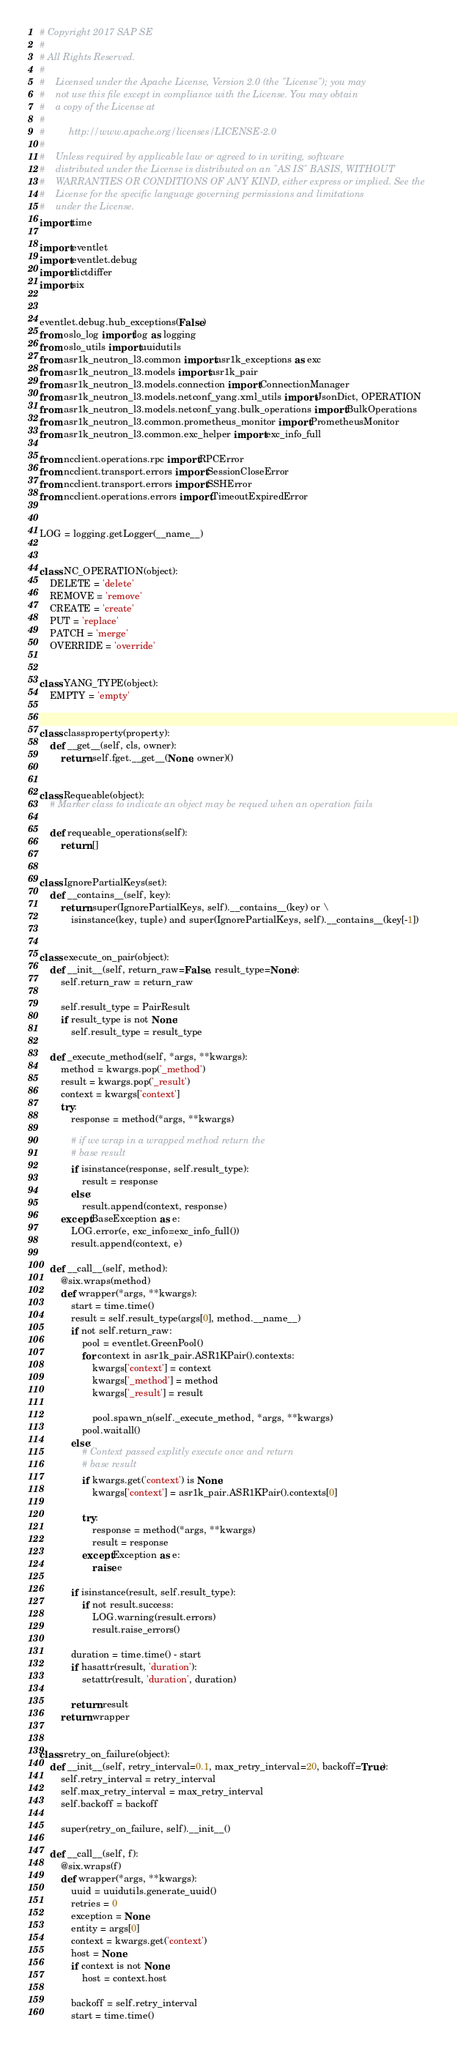<code> <loc_0><loc_0><loc_500><loc_500><_Python_># Copyright 2017 SAP SE
#
# All Rights Reserved.
#
#    Licensed under the Apache License, Version 2.0 (the "License"); you may
#    not use this file except in compliance with the License. You may obtain
#    a copy of the License at
#
#         http://www.apache.org/licenses/LICENSE-2.0
#
#    Unless required by applicable law or agreed to in writing, software
#    distributed under the License is distributed on an "AS IS" BASIS, WITHOUT
#    WARRANTIES OR CONDITIONS OF ANY KIND, either express or implied. See the
#    License for the specific language governing permissions and limitations
#    under the License.
import time

import eventlet
import eventlet.debug
import dictdiffer
import six


eventlet.debug.hub_exceptions(False)
from oslo_log import log as logging
from oslo_utils import uuidutils
from asr1k_neutron_l3.common import asr1k_exceptions as exc
from asr1k_neutron_l3.models import asr1k_pair
from asr1k_neutron_l3.models.connection import ConnectionManager
from asr1k_neutron_l3.models.netconf_yang.xml_utils import JsonDict, OPERATION
from asr1k_neutron_l3.models.netconf_yang.bulk_operations import BulkOperations
from asr1k_neutron_l3.common.prometheus_monitor import PrometheusMonitor
from asr1k_neutron_l3.common.exc_helper import exc_info_full

from ncclient.operations.rpc import RPCError
from ncclient.transport.errors import SessionCloseError
from ncclient.transport.errors import SSHError
from ncclient.operations.errors import TimeoutExpiredError


LOG = logging.getLogger(__name__)


class NC_OPERATION(object):
    DELETE = 'delete'
    REMOVE = 'remove'
    CREATE = 'create'
    PUT = 'replace'
    PATCH = 'merge'
    OVERRIDE = 'override'


class YANG_TYPE(object):
    EMPTY = 'empty'


class classproperty(property):
    def __get__(self, cls, owner):
        return self.fget.__get__(None, owner)()


class Requeable(object):
    # Marker class to indicate an object may be requed when an operation fails

    def requeable_operations(self):
        return []


class IgnorePartialKeys(set):
    def __contains__(self, key):
        return super(IgnorePartialKeys, self).__contains__(key) or \
            isinstance(key, tuple) and super(IgnorePartialKeys, self).__contains__(key[-1])


class execute_on_pair(object):
    def __init__(self, return_raw=False, result_type=None):
        self.return_raw = return_raw

        self.result_type = PairResult
        if result_type is not None:
            self.result_type = result_type

    def _execute_method(self, *args, **kwargs):
        method = kwargs.pop('_method')
        result = kwargs.pop('_result')
        context = kwargs['context']
        try:
            response = method(*args, **kwargs)

            # if we wrap in a wrapped method return the
            # base result
            if isinstance(response, self.result_type):
                result = response
            else:
                result.append(context, response)
        except BaseException as e:
            LOG.error(e, exc_info=exc_info_full())
            result.append(context, e)

    def __call__(self, method):
        @six.wraps(method)
        def wrapper(*args, **kwargs):
            start = time.time()
            result = self.result_type(args[0], method.__name__)
            if not self.return_raw:
                pool = eventlet.GreenPool()
                for context in asr1k_pair.ASR1KPair().contexts:
                    kwargs['context'] = context
                    kwargs['_method'] = method
                    kwargs['_result'] = result

                    pool.spawn_n(self._execute_method, *args, **kwargs)
                pool.waitall()
            else:
                # Context passed explitly execute once and return
                # base result
                if kwargs.get('context') is None:
                    kwargs['context'] = asr1k_pair.ASR1KPair().contexts[0]

                try:
                    response = method(*args, **kwargs)
                    result = response
                except Exception as e:
                    raise e

            if isinstance(result, self.result_type):
                if not result.success:
                    LOG.warning(result.errors)
                    result.raise_errors()

            duration = time.time() - start
            if hasattr(result, 'duration'):
                setattr(result, 'duration', duration)

            return result
        return wrapper


class retry_on_failure(object):
    def __init__(self, retry_interval=0.1, max_retry_interval=20, backoff=True):
        self.retry_interval = retry_interval
        self.max_retry_interval = max_retry_interval
        self.backoff = backoff

        super(retry_on_failure, self).__init__()

    def __call__(self, f):
        @six.wraps(f)
        def wrapper(*args, **kwargs):
            uuid = uuidutils.generate_uuid()
            retries = 0
            exception = None
            entity = args[0]
            context = kwargs.get('context')
            host = None
            if context is not None:
                host = context.host

            backoff = self.retry_interval
            start = time.time()</code> 